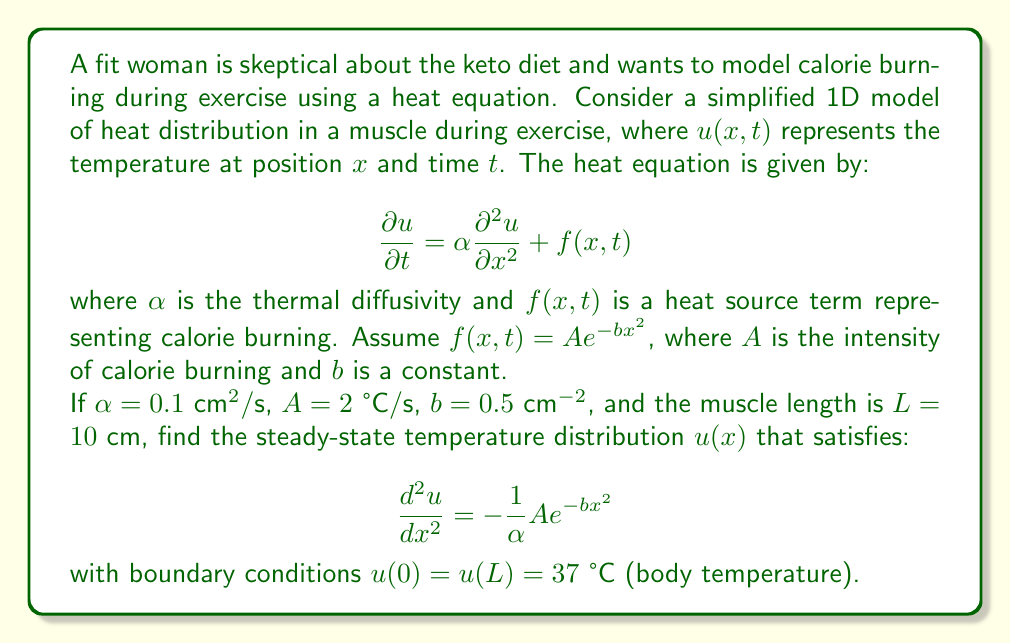Teach me how to tackle this problem. To solve this problem, we need to follow these steps:

1) The steady-state equation is:

   $$\frac{d^2u}{dx^2} = -\frac{1}{\alpha}A e^{-bx^2}$$

2) Substitute the given values:

   $$\frac{d^2u}{dx^2} = -\frac{1}{0.1} \cdot 2 \cdot e^{-0.5x^2} = -20e^{-0.5x^2}$$

3) To solve this, we need to integrate twice:

   $$\frac{du}{dx} = -20 \int e^{-0.5x^2} dx + C_1$$

   The integral of $e^{-ax^2}$ is $\frac{\sqrt{\pi}}{2\sqrt{a}} \text{erf}(\sqrt{a}x)$, where erf is the error function.

   $$\frac{du}{dx} = -20 \cdot \sqrt{\frac{\pi}{2}} \text{erf}(\frac{x}{\sqrt{2}}) + C_1$$

4) Integrate again:

   $$u(x) = -20 \cdot \sqrt{\frac{\pi}{2}} \int \text{erf}(\frac{x}{\sqrt{2}}) dx + C_1x + C_2$$

   The integral of erf(x) is $x \cdot \text{erf}(x) + \frac{1}{\sqrt{\pi}}e^{-x^2}$

   $$u(x) = -20 \cdot \sqrt{\frac{\pi}{2}} \left[\frac{x}{\sqrt{2}} \cdot \text{erf}(\frac{x}{\sqrt{2}}) + \frac{1}{\sqrt{\pi}}e^{-\frac{x^2}{2}}\right] + C_1x + C_2$$

5) Now we use the boundary conditions to find $C_1$ and $C_2$:

   At $x = 0$: $u(0) = 37 = -20 \cdot \frac{1}{\sqrt{2}} + C_2$
   
   At $x = 10$: $u(10) = 37 = -20 \cdot \sqrt{\frac{\pi}{2}} \left[\frac{10}{\sqrt{2}} \cdot \text{erf}(\frac{10}{\sqrt{2}}) + \frac{1}{\sqrt{\pi}}e^{-50}\right] + 10C_1 + C_2$

6) Solving these equations gives us:

   $C_2 = 37 + 20 \cdot \frac{1}{\sqrt{2}} \approx 51.14$
   
   $C_1 \approx -1.41$

7) Therefore, the final solution is:

   $$u(x) = -20 \cdot \sqrt{\frac{\pi}{2}} \left[\frac{x}{\sqrt{2}} \cdot \text{erf}(\frac{x}{\sqrt{2}}) + \frac{1}{\sqrt{\pi}}e^{-\frac{x^2}{2}}\right] - 1.41x + 51.14$$

This equation represents the steady-state temperature distribution in the muscle during exercise.
Answer: The steady-state temperature distribution is given by:

$$u(x) = -20 \cdot \sqrt{\frac{\pi}{2}} \left[\frac{x}{\sqrt{2}} \cdot \text{erf}(\frac{x}{\sqrt{2}}) + \frac{1}{\sqrt{\pi}}e^{-\frac{x^2}{2}}\right] - 1.41x + 51.14$$

where $x$ is the position along the muscle (in cm), and $u(x)$ is the temperature (in °C). 